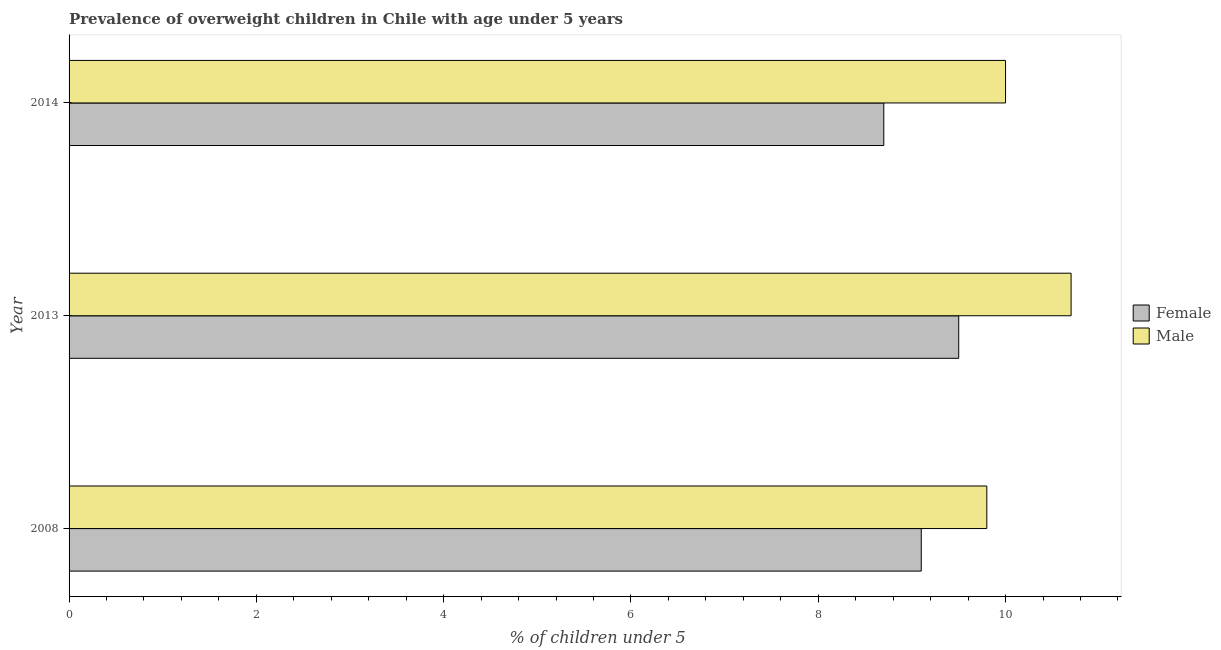Are the number of bars per tick equal to the number of legend labels?
Your answer should be very brief. Yes. How many bars are there on the 1st tick from the top?
Keep it short and to the point. 2. How many bars are there on the 3rd tick from the bottom?
Your response must be concise. 2. What is the percentage of obese male children in 2014?
Your response must be concise. 10. Across all years, what is the minimum percentage of obese female children?
Offer a very short reply. 8.7. What is the total percentage of obese female children in the graph?
Offer a terse response. 27.3. What is the difference between the percentage of obese male children in 2008 and that in 2013?
Your answer should be very brief. -0.9. What is the difference between the percentage of obese male children in 2008 and the percentage of obese female children in 2013?
Provide a succinct answer. 0.3. In the year 2014, what is the difference between the percentage of obese female children and percentage of obese male children?
Your answer should be very brief. -1.3. What is the ratio of the percentage of obese female children in 2013 to that in 2014?
Offer a terse response. 1.09. Is the percentage of obese female children in 2008 less than that in 2014?
Your answer should be compact. No. What is the difference between the highest and the lowest percentage of obese female children?
Give a very brief answer. 0.8. In how many years, is the percentage of obese female children greater than the average percentage of obese female children taken over all years?
Your answer should be very brief. 2. What does the 2nd bar from the top in 2008 represents?
Offer a very short reply. Female. How many bars are there?
Ensure brevity in your answer.  6. What is the difference between two consecutive major ticks on the X-axis?
Offer a terse response. 2. Does the graph contain any zero values?
Give a very brief answer. No. Does the graph contain grids?
Keep it short and to the point. No. What is the title of the graph?
Your answer should be very brief. Prevalence of overweight children in Chile with age under 5 years. What is the label or title of the X-axis?
Ensure brevity in your answer.   % of children under 5. What is the  % of children under 5 in Female in 2008?
Ensure brevity in your answer.  9.1. What is the  % of children under 5 of Male in 2008?
Make the answer very short. 9.8. What is the  % of children under 5 in Female in 2013?
Offer a terse response. 9.5. What is the  % of children under 5 of Male in 2013?
Your answer should be compact. 10.7. What is the  % of children under 5 in Female in 2014?
Your response must be concise. 8.7. What is the  % of children under 5 in Male in 2014?
Your response must be concise. 10. Across all years, what is the maximum  % of children under 5 in Male?
Your response must be concise. 10.7. Across all years, what is the minimum  % of children under 5 of Female?
Provide a short and direct response. 8.7. Across all years, what is the minimum  % of children under 5 of Male?
Your response must be concise. 9.8. What is the total  % of children under 5 in Female in the graph?
Your answer should be very brief. 27.3. What is the total  % of children under 5 of Male in the graph?
Make the answer very short. 30.5. What is the difference between the  % of children under 5 in Female in 2008 and that in 2013?
Keep it short and to the point. -0.4. What is the difference between the  % of children under 5 in Female in 2008 and the  % of children under 5 in Male in 2014?
Ensure brevity in your answer.  -0.9. What is the average  % of children under 5 of Female per year?
Your answer should be compact. 9.1. What is the average  % of children under 5 in Male per year?
Give a very brief answer. 10.17. In the year 2008, what is the difference between the  % of children under 5 of Female and  % of children under 5 of Male?
Your response must be concise. -0.7. What is the ratio of the  % of children under 5 in Female in 2008 to that in 2013?
Give a very brief answer. 0.96. What is the ratio of the  % of children under 5 of Male in 2008 to that in 2013?
Your response must be concise. 0.92. What is the ratio of the  % of children under 5 of Female in 2008 to that in 2014?
Keep it short and to the point. 1.05. What is the ratio of the  % of children under 5 in Male in 2008 to that in 2014?
Offer a terse response. 0.98. What is the ratio of the  % of children under 5 of Female in 2013 to that in 2014?
Your answer should be very brief. 1.09. What is the ratio of the  % of children under 5 of Male in 2013 to that in 2014?
Offer a terse response. 1.07. What is the difference between the highest and the second highest  % of children under 5 of Male?
Offer a very short reply. 0.7. What is the difference between the highest and the lowest  % of children under 5 of Female?
Your answer should be compact. 0.8. 